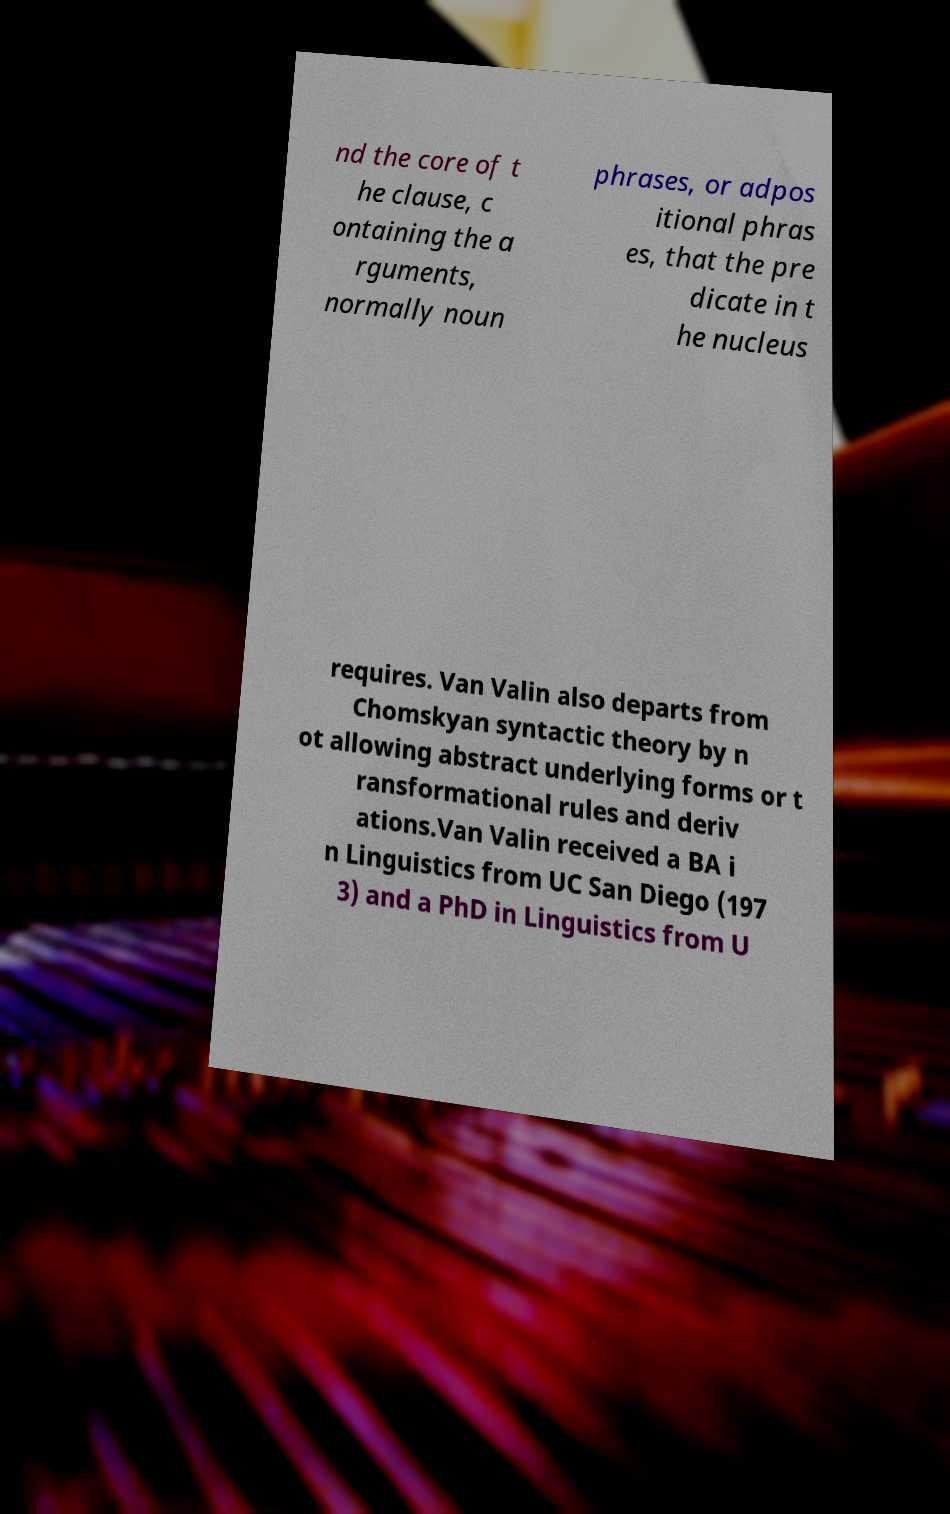There's text embedded in this image that I need extracted. Can you transcribe it verbatim? nd the core of t he clause, c ontaining the a rguments, normally noun phrases, or adpos itional phras es, that the pre dicate in t he nucleus requires. Van Valin also departs from Chomskyan syntactic theory by n ot allowing abstract underlying forms or t ransformational rules and deriv ations.Van Valin received a BA i n Linguistics from UC San Diego (197 3) and a PhD in Linguistics from U 